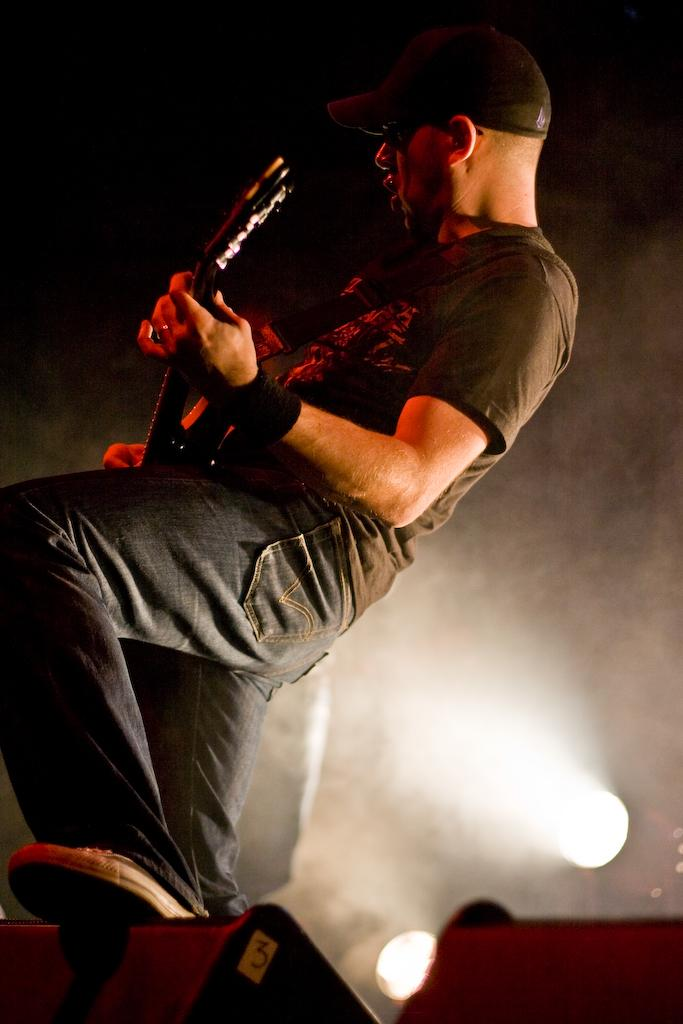What is the main subject of the image? There is a person in the image. What is the person doing in the image? The person is playing a guitar. What type of bead is being used as a guitar pick in the image? There is no bead present in the image, nor is there any indication that a bead is being used as a guitar pick. 